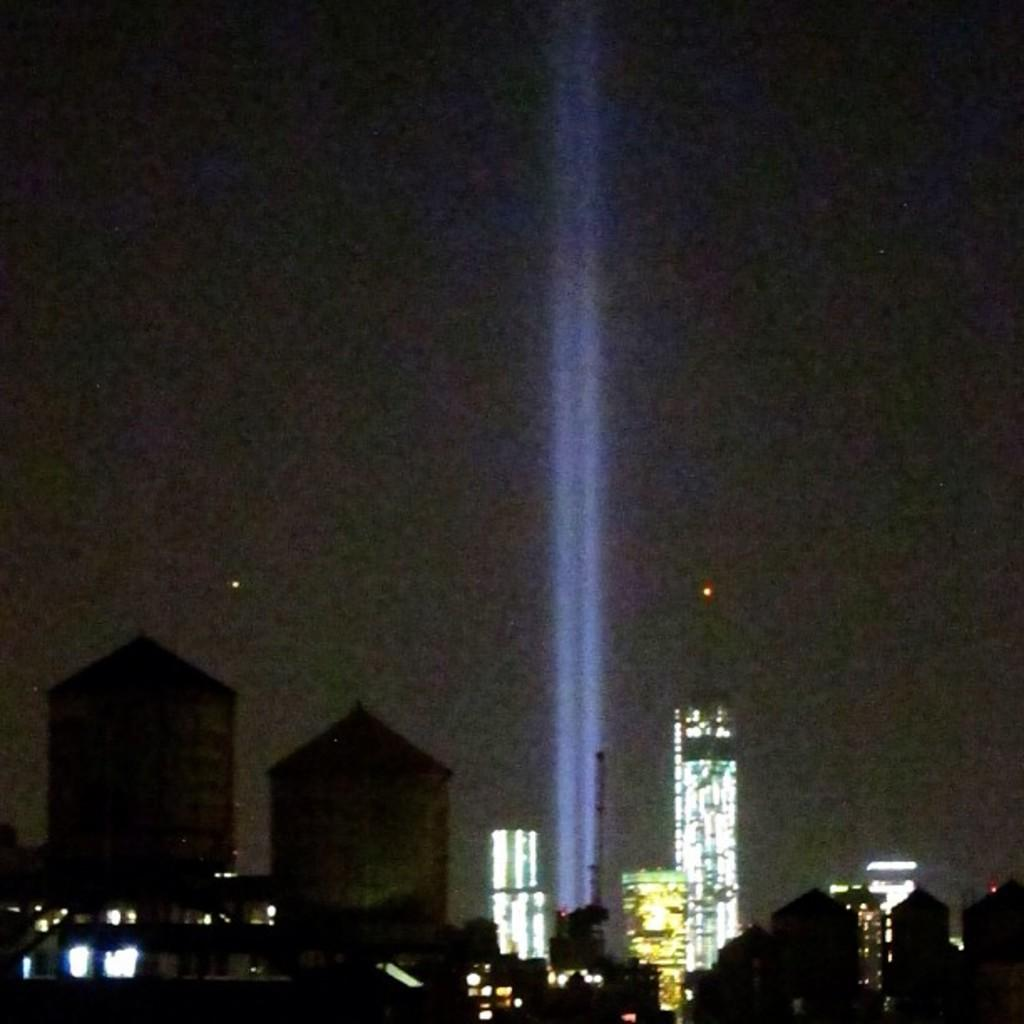What type of location is depicted in the image? The image is of a city. What can be seen at the bottom of the image? There are skyscrapers and buildings at the bottom of the image. What is present at the bottom of the image that might provide illumination? There are lights at the bottom of the image. How would you describe the sky at the top of the image? The sky is dark at the top of the image. What else can be seen in the center of the image that provides illumination? There are lights in the center of the image. What type of baseball team is represented by the company logo on the dress in the image? There is no baseball team, company logo, or dress present in the image. 